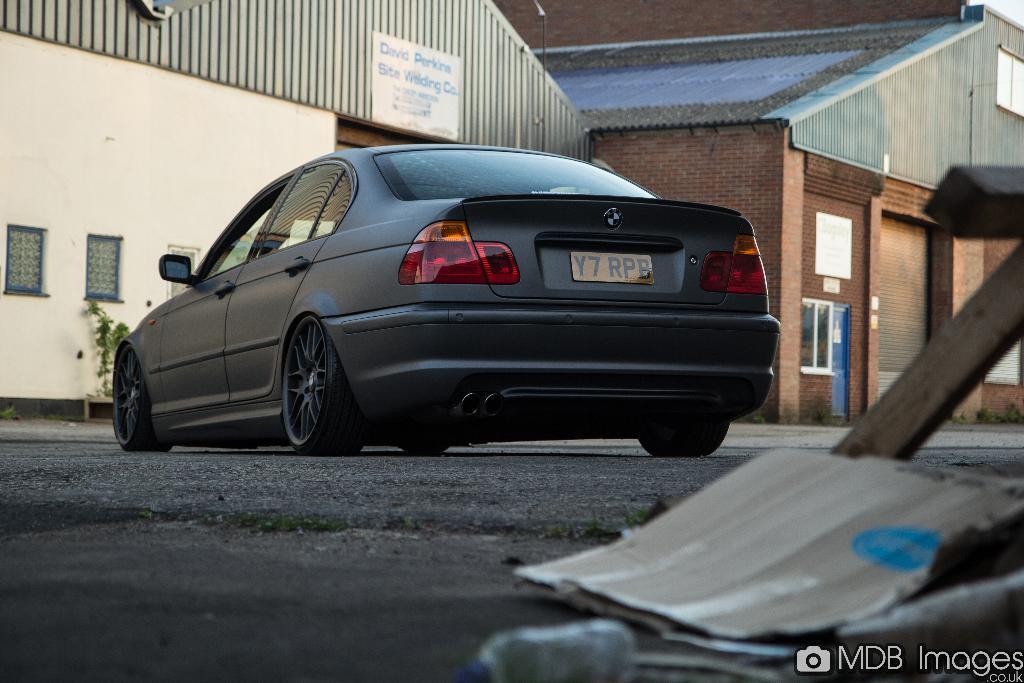Please provide a concise description of this image. In this image we can see a car on the road. In the background of the image there are houses. At the bottom of the image there is some text. 